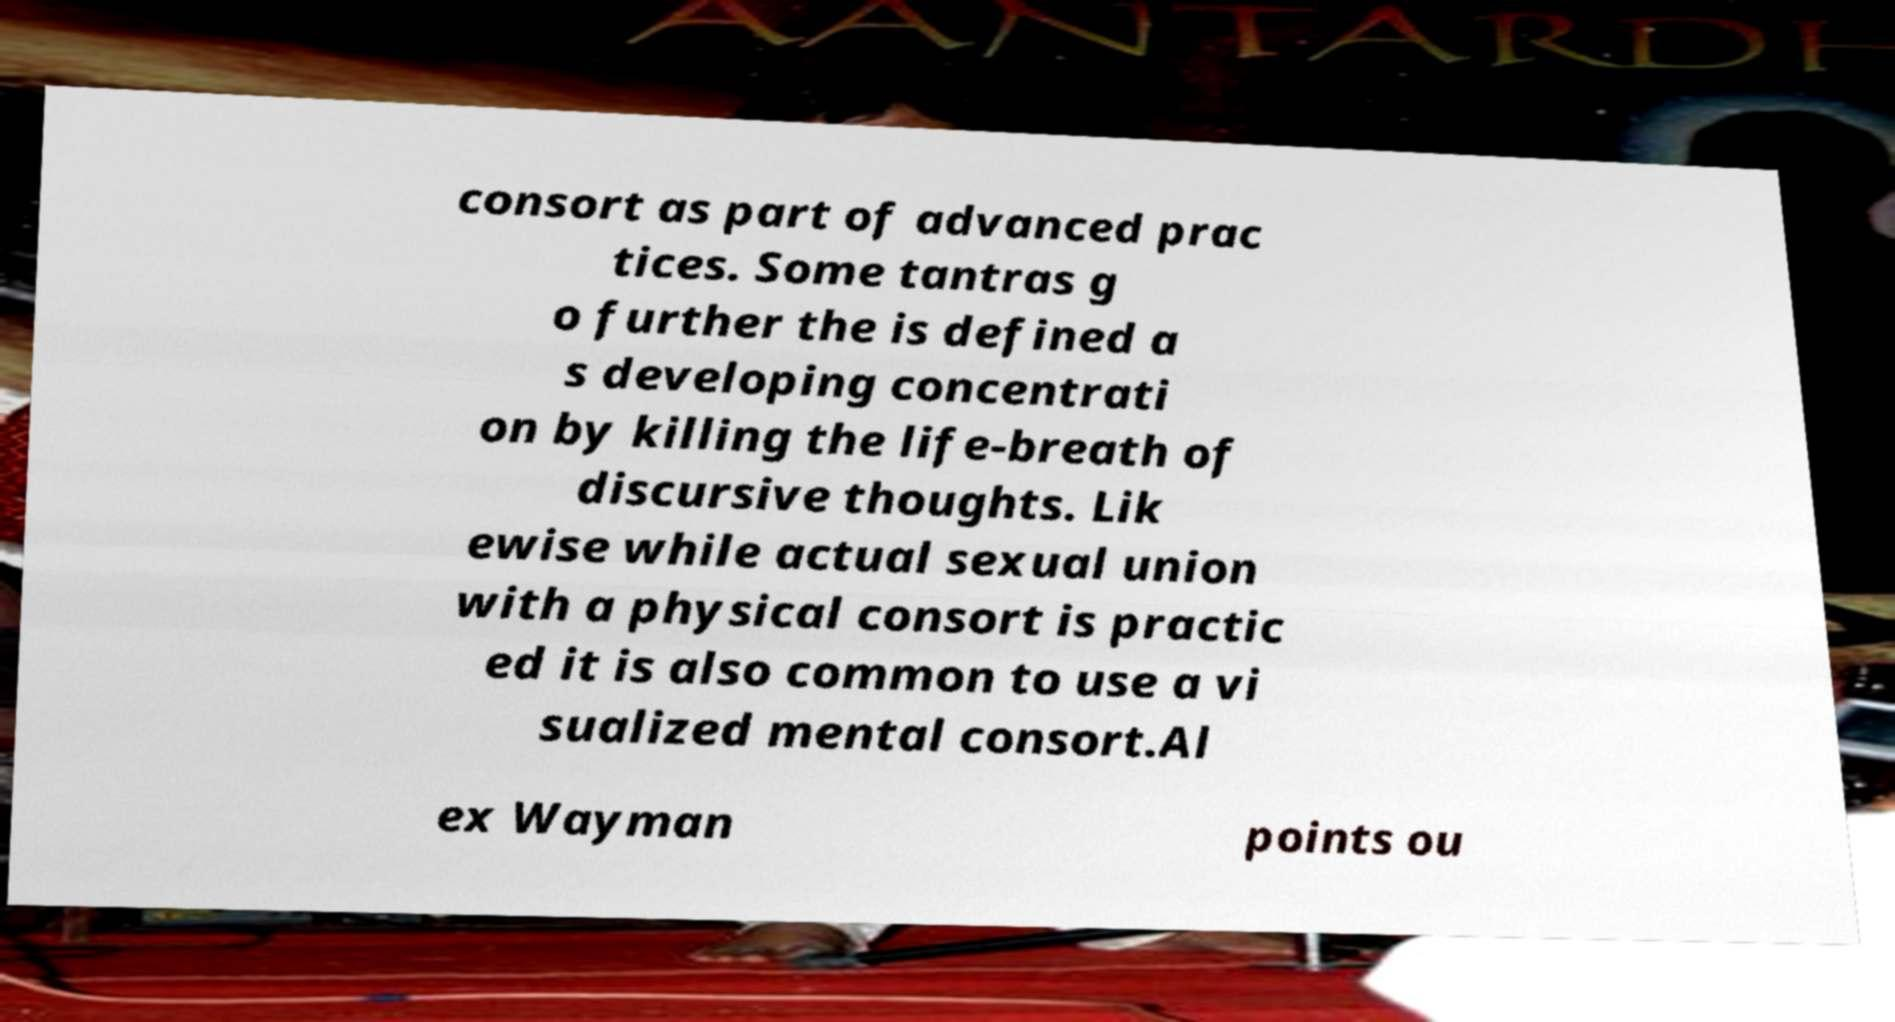Please identify and transcribe the text found in this image. consort as part of advanced prac tices. Some tantras g o further the is defined a s developing concentrati on by killing the life-breath of discursive thoughts. Lik ewise while actual sexual union with a physical consort is practic ed it is also common to use a vi sualized mental consort.Al ex Wayman points ou 